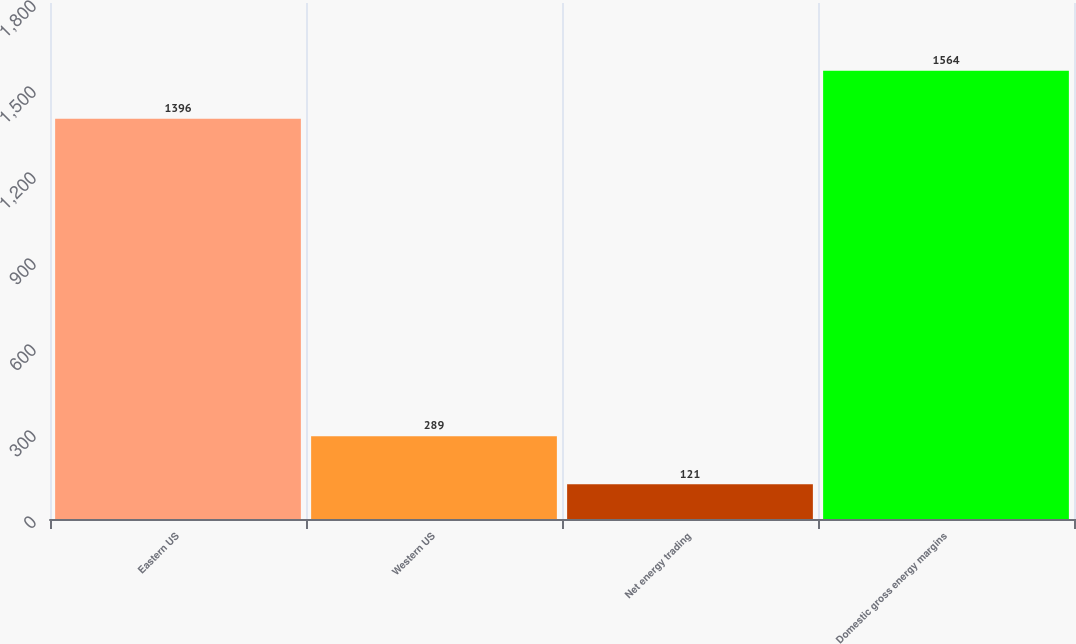Convert chart to OTSL. <chart><loc_0><loc_0><loc_500><loc_500><bar_chart><fcel>Eastern US<fcel>Western US<fcel>Net energy trading<fcel>Domestic gross energy margins<nl><fcel>1396<fcel>289<fcel>121<fcel>1564<nl></chart> 